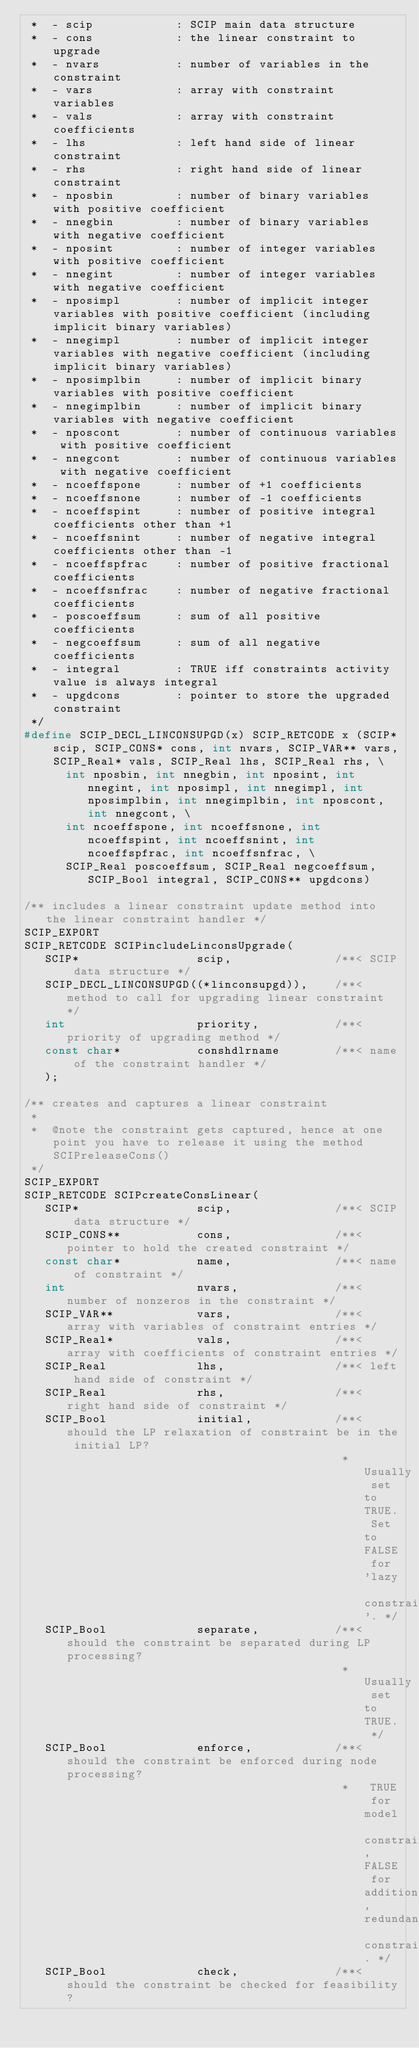<code> <loc_0><loc_0><loc_500><loc_500><_C_> *  - scip            : SCIP main data structure
 *  - cons            : the linear constraint to upgrade
 *  - nvars           : number of variables in the constraint
 *  - vars            : array with constraint variables
 *  - vals            : array with constraint coefficients
 *  - lhs             : left hand side of linear constraint
 *  - rhs             : right hand side of linear constraint
 *  - nposbin         : number of binary variables with positive coefficient
 *  - nnegbin         : number of binary variables with negative coefficient
 *  - nposint         : number of integer variables with positive coefficient
 *  - nnegint         : number of integer variables with negative coefficient
 *  - nposimpl        : number of implicit integer variables with positive coefficient (including implicit binary variables)
 *  - nnegimpl        : number of implicit integer variables with negative coefficient (including implicit binary variables)
 *  - nposimplbin     : number of implicit binary variables with positive coefficient
 *  - nnegimplbin     : number of implicit binary variables with negative coefficient
 *  - nposcont        : number of continuous variables with positive coefficient
 *  - nnegcont        : number of continuous variables with negative coefficient
 *  - ncoeffspone     : number of +1 coefficients
 *  - ncoeffsnone     : number of -1 coefficients
 *  - ncoeffspint     : number of positive integral coefficients other than +1
 *  - ncoeffsnint     : number of negative integral coefficients other than -1
 *  - ncoeffspfrac    : number of positive fractional coefficients
 *  - ncoeffsnfrac    : number of negative fractional coefficients
 *  - poscoeffsum     : sum of all positive coefficients
 *  - negcoeffsum     : sum of all negative coefficients
 *  - integral        : TRUE iff constraints activity value is always integral
 *  - upgdcons        : pointer to store the upgraded constraint
 */
#define SCIP_DECL_LINCONSUPGD(x) SCIP_RETCODE x (SCIP* scip, SCIP_CONS* cons, int nvars, SCIP_VAR** vars, SCIP_Real* vals, SCIP_Real lhs, SCIP_Real rhs, \
      int nposbin, int nnegbin, int nposint, int nnegint, int nposimpl, int nnegimpl, int nposimplbin, int nnegimplbin, int nposcont, int nnegcont, \
      int ncoeffspone, int ncoeffsnone, int ncoeffspint, int ncoeffsnint, int ncoeffspfrac, int ncoeffsnfrac, \
      SCIP_Real poscoeffsum, SCIP_Real negcoeffsum, SCIP_Bool integral, SCIP_CONS** upgdcons)

/** includes a linear constraint update method into the linear constraint handler */
SCIP_EXPORT
SCIP_RETCODE SCIPincludeLinconsUpgrade(
   SCIP*                 scip,               /**< SCIP data structure */
   SCIP_DECL_LINCONSUPGD((*linconsupgd)),    /**< method to call for upgrading linear constraint */
   int                   priority,           /**< priority of upgrading method */
   const char*           conshdlrname        /**< name of the constraint handler */
   );

/** creates and captures a linear constraint
 *
 *  @note the constraint gets captured, hence at one point you have to release it using the method SCIPreleaseCons()
 */
SCIP_EXPORT
SCIP_RETCODE SCIPcreateConsLinear(
   SCIP*                 scip,               /**< SCIP data structure */
   SCIP_CONS**           cons,               /**< pointer to hold the created constraint */
   const char*           name,               /**< name of constraint */
   int                   nvars,              /**< number of nonzeros in the constraint */
   SCIP_VAR**            vars,               /**< array with variables of constraint entries */
   SCIP_Real*            vals,               /**< array with coefficients of constraint entries */
   SCIP_Real             lhs,                /**< left hand side of constraint */
   SCIP_Real             rhs,                /**< right hand side of constraint */
   SCIP_Bool             initial,            /**< should the LP relaxation of constraint be in the initial LP?
                                              *   Usually set to TRUE. Set to FALSE for 'lazy constraints'. */
   SCIP_Bool             separate,           /**< should the constraint be separated during LP processing?
                                              *   Usually set to TRUE. */
   SCIP_Bool             enforce,            /**< should the constraint be enforced during node processing?
                                              *   TRUE for model constraints, FALSE for additional, redundant constraints. */
   SCIP_Bool             check,              /**< should the constraint be checked for feasibility?</code> 